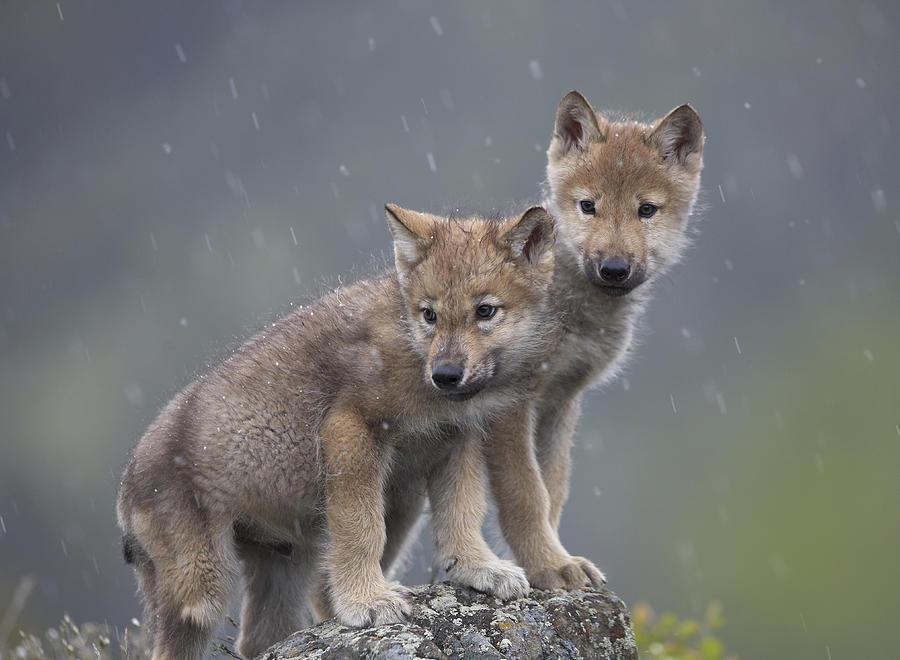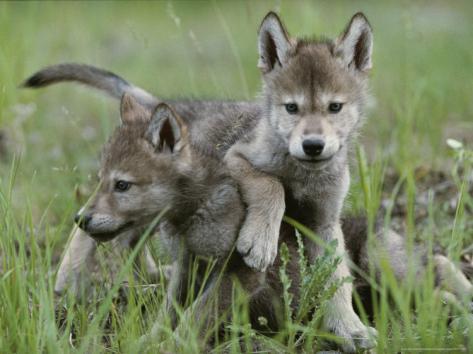The first image is the image on the left, the second image is the image on the right. Examine the images to the left and right. Is the description "An image includes a wild dog bending down toward the carcass of an animal." accurate? Answer yes or no. No. The first image is the image on the left, the second image is the image on the right. For the images displayed, is the sentence "The left image contains exactly two baby wolves." factually correct? Answer yes or no. Yes. 